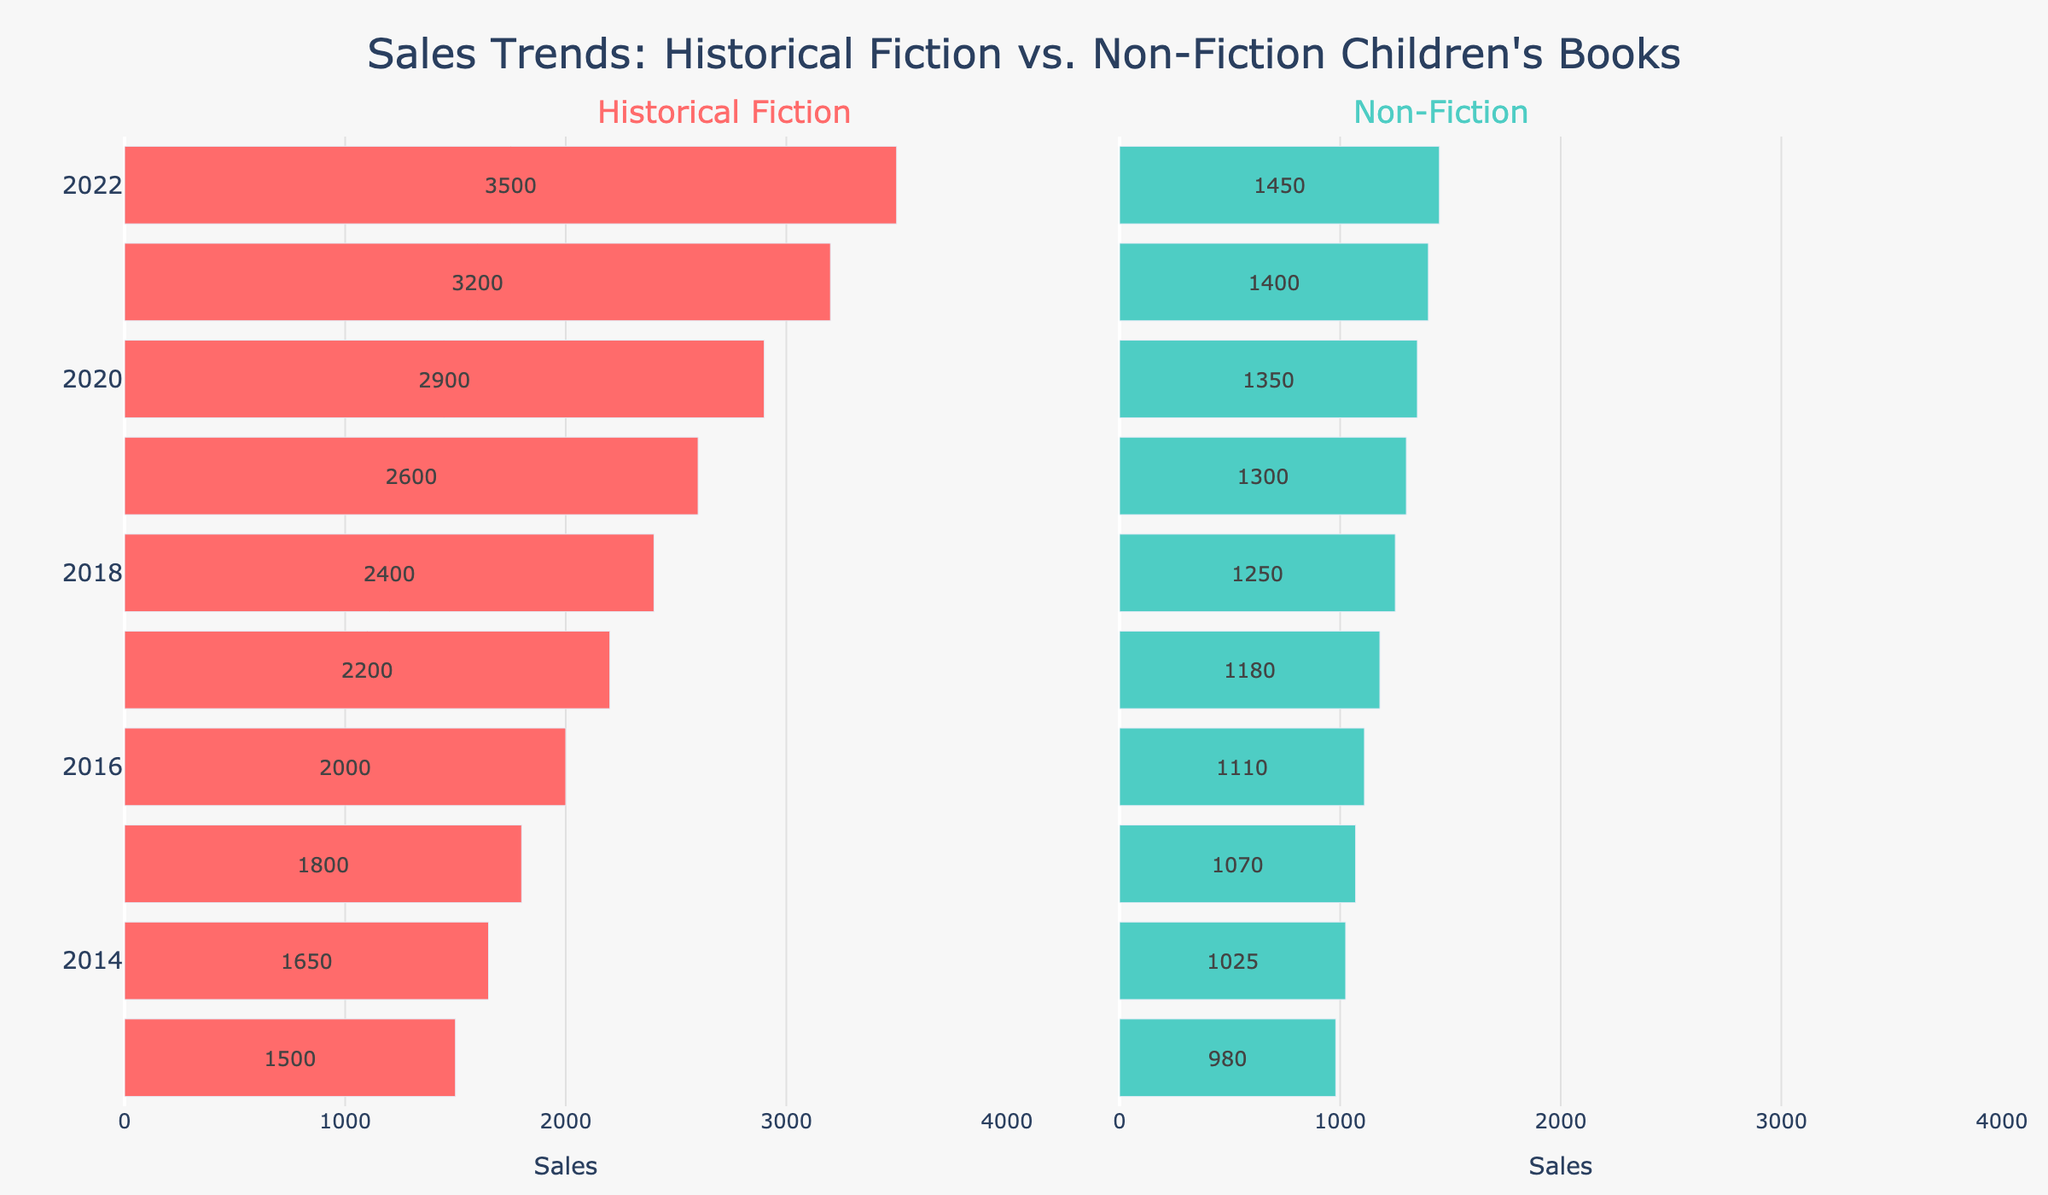How do the sales of Historical Fiction books compare to Non-Fiction books in 2022? By referring to the figure, the sales for Historical Fiction in 2022 appear significantly higher than the sales for Non-Fiction in the same year. The exact sales values can be found on the bars: Historical Fiction has 3500 and Non-Fiction has 1450.
Answer: Historical Fiction sales are higher What is the average sales of Non-Fiction books from 2013 to 2015? To calculate the average, sum the sales values from 2013 to 2015: (980 + 1025 + 1070) = 3075. There are 3 years, so the average is 3075/3.
Answer: 1025 By how much did Historical Fiction sales increase from 2015 to 2020? Subtract the sales of Historical Fiction in 2015 from the sales in 2020: 2900 - 1800 = 1100.
Answer: 1100 Which category had the highest sales in 2019, and what were the sales figures? Compare the sales of Historical Fiction and Non-Fiction in 2019. Historical Fiction sales are 2600, and Non-Fiction sales are 1300. Historical Fiction had the highest sales.
Answer: Historical Fiction, 2600 By how much did Non-Fiction sales increase from 2013 to 2022? Subtract the sales of Non-Fiction in 2013 from the sales in 2022: 1450 - 980 = 470.
Answer: 470 What is the trend in sales for Historical Fiction books over the past decade? The sales of Historical Fiction have steadily increased from 1500 in 2013 to 3500 in 2022. This is observed by the increasing length of the bars representing Historical Fiction over the years.
Answer: Increasing trend What is the difference between the highest and lowest sales figures for Non-Fiction books? The highest sales figure for Non-Fiction is in 2022 with 1450 and the lowest is in 2013 with 980. The difference is 1450 - 980 = 470.
Answer: 470 Which year saw the highest sales for Non-Fiction books and what was the sales figure? By examining the Non-Fiction bar lengths, 2022 has the highest sales, with a value of 1450.
Answer: 2022, 1450 How do the sales trends of Historical Fiction compare to Non-Fiction over the years? Historical Fiction sales have continuously increased each year from 2013 to 2022, whereas Non-Fiction sales have also increased but at a slower and less dramatic rate. This can be seen by comparing the bar lengths for each category over the years.
Answer: Historical Fiction has a stronger increase What was the sum of sales for Historical Fiction books in the first half of the decade (2013-2017)? The sales for Historical Fiction from 2013 to 2017 are: 1500 + 1650 + 1800 + 2000 + 2200 = 9150.
Answer: 9150 